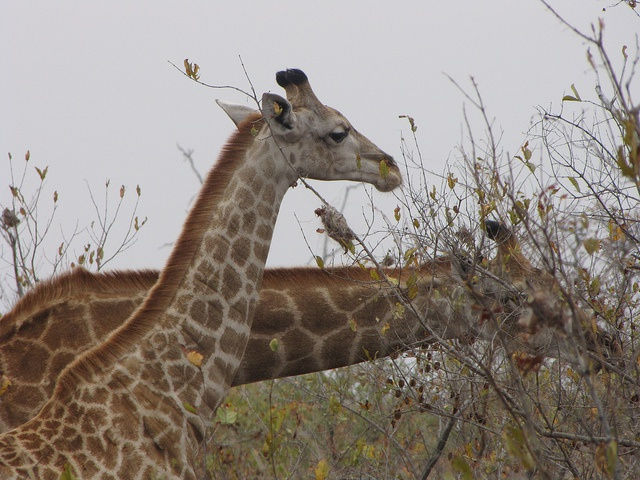Describe the objects in this image and their specific colors. I can see giraffe in lightgray, gray, and maroon tones and giraffe in lightgray, maroon, gray, and black tones in this image. 